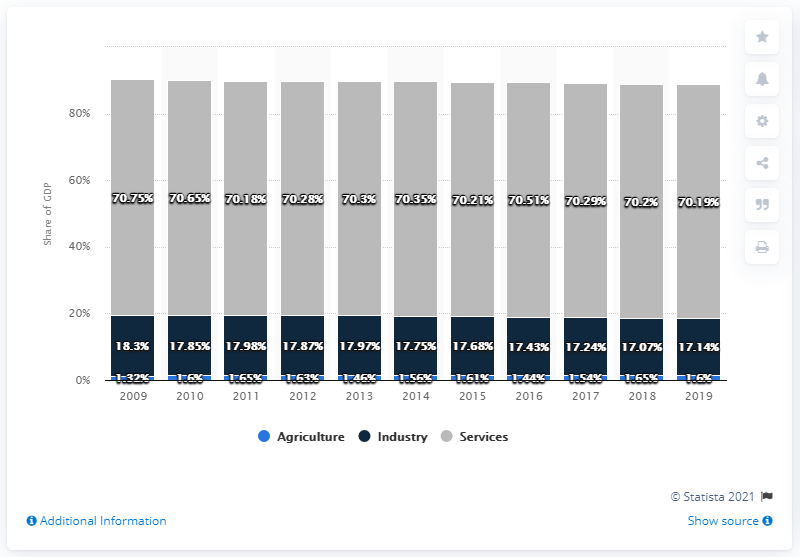Specify some key components in this picture. In 2019, approximately 70.19% of France's Gross Domestic Product (GDP) was attributed to services. 